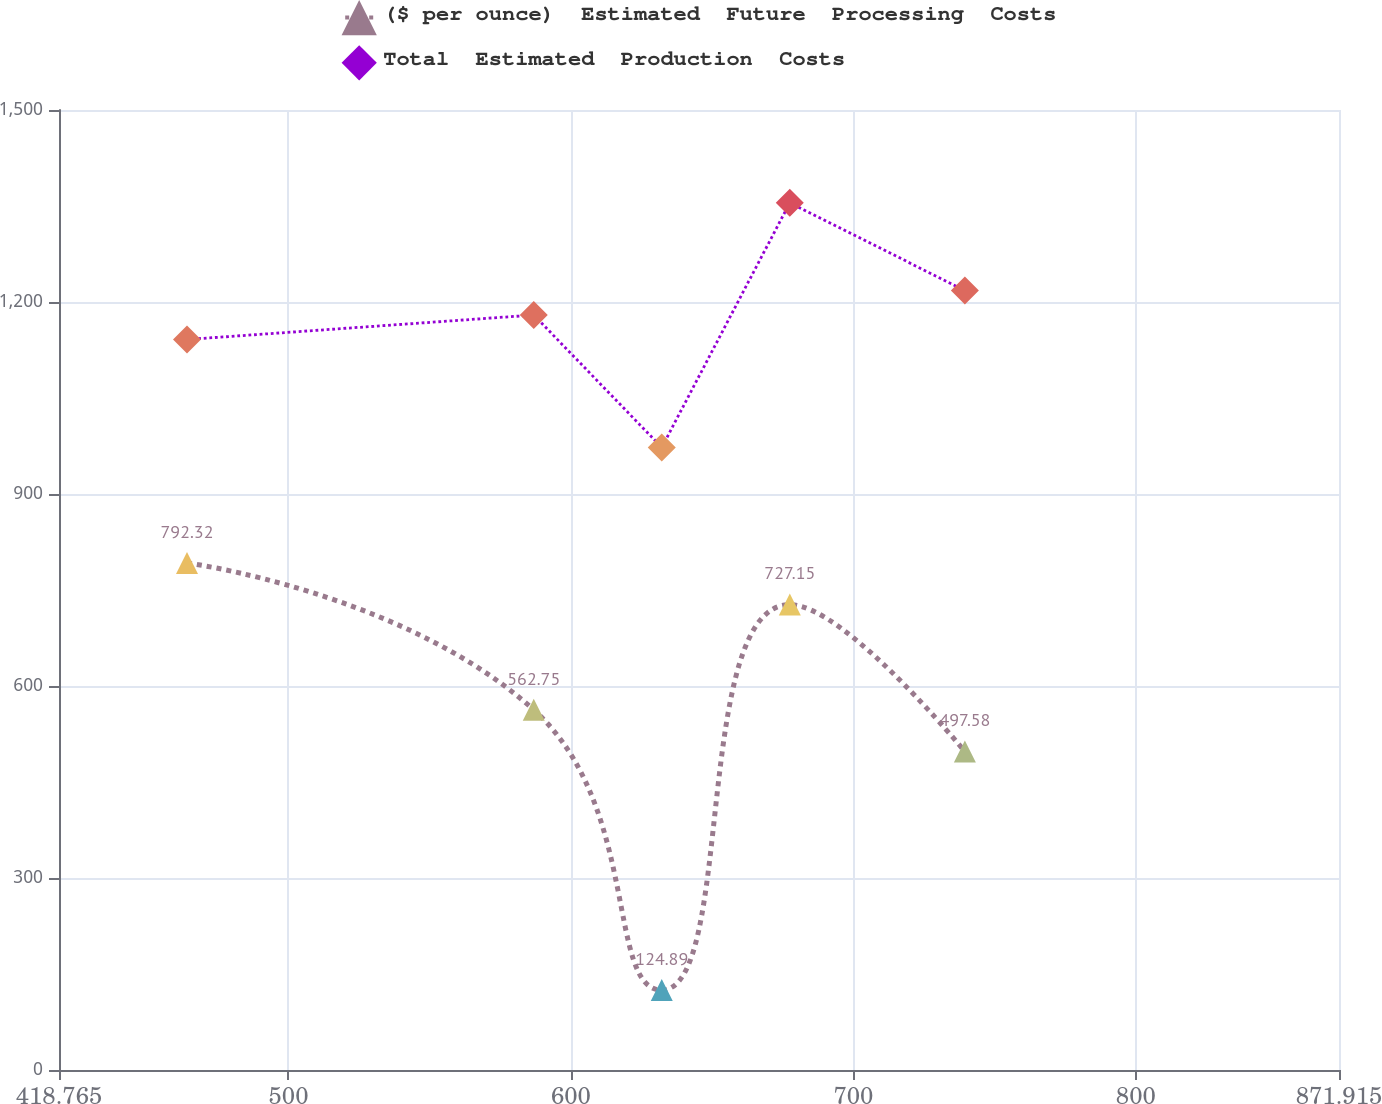Convert chart to OTSL. <chart><loc_0><loc_0><loc_500><loc_500><line_chart><ecel><fcel>($ per ounce)  Estimated  Future  Processing  Costs<fcel>Total  Estimated  Production  Costs<nl><fcel>464.08<fcel>792.32<fcel>1141.42<nl><fcel>586.84<fcel>562.75<fcel>1179.64<nl><fcel>632.16<fcel>124.89<fcel>972.8<nl><fcel>677.48<fcel>727.15<fcel>1355<nl><fcel>739.47<fcel>497.58<fcel>1217.86<nl><fcel>917.23<fcel>627.92<fcel>1082.14<nl></chart> 